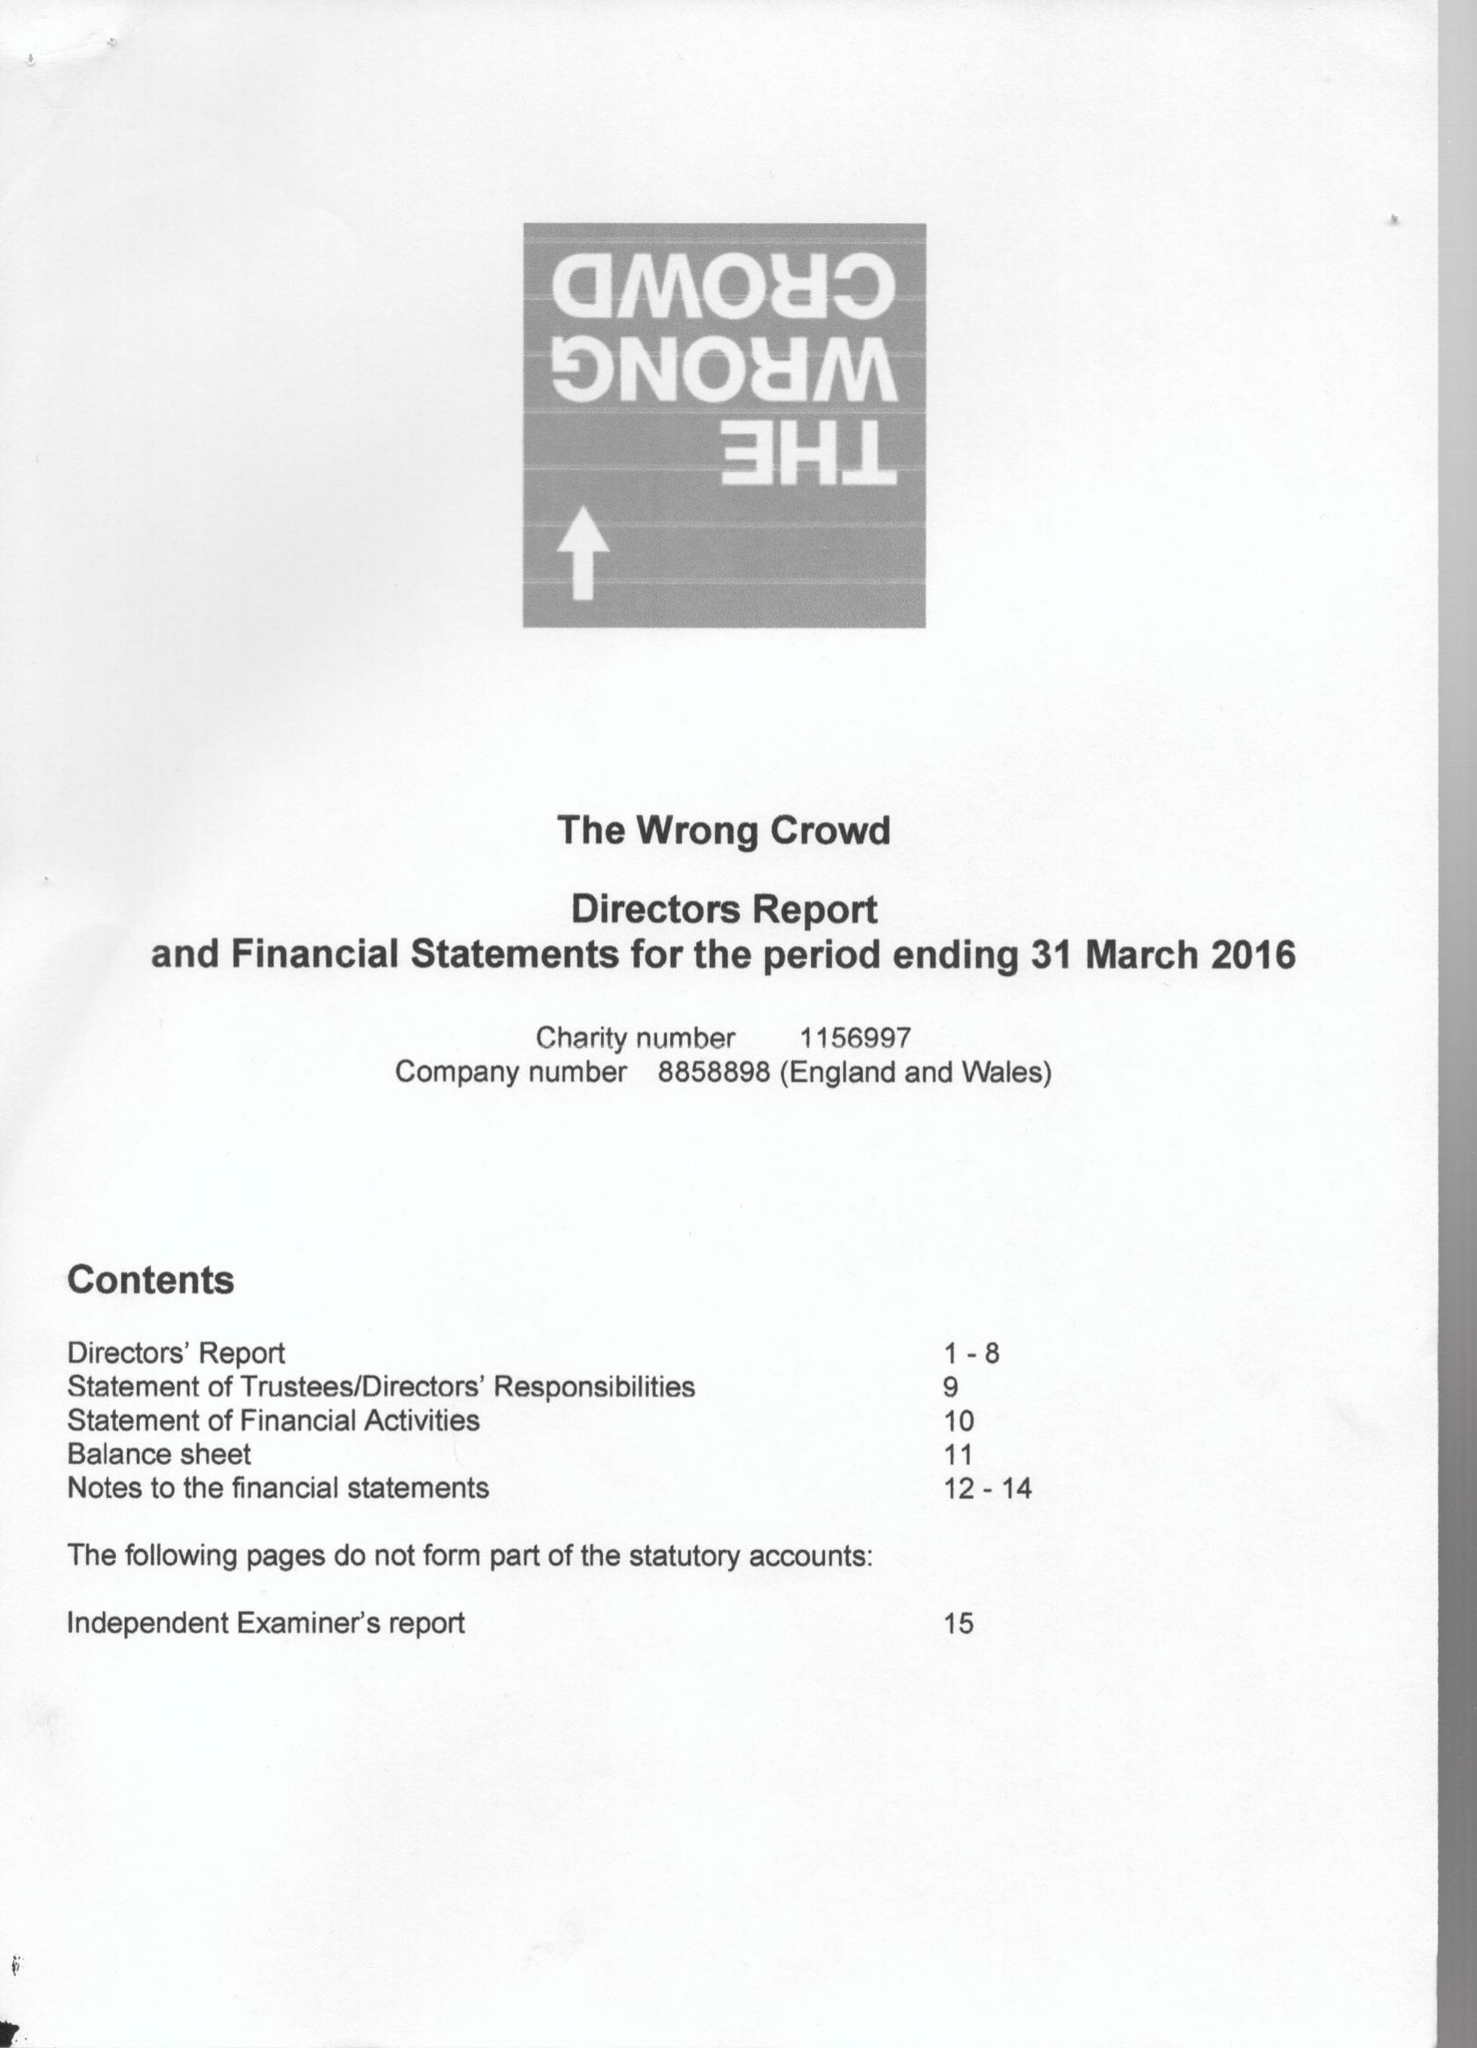What is the value for the income_annually_in_british_pounds?
Answer the question using a single word or phrase. 226403.00 